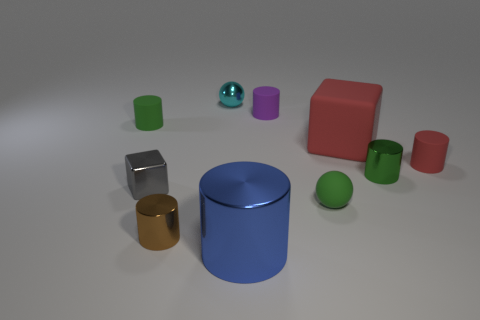There is a green rubber thing that is in front of the red rubber thing in front of the red cube; what shape is it?
Offer a very short reply. Sphere. Is there a blue ball made of the same material as the tiny brown cylinder?
Keep it short and to the point. No. There is a cylinder that is the same color as the large rubber object; what is its size?
Provide a short and direct response. Small. How many red objects are rubber cylinders or cubes?
Make the answer very short. 2. Are there any matte things of the same color as the big block?
Make the answer very short. Yes. What is the size of the blue cylinder that is made of the same material as the brown cylinder?
Offer a very short reply. Large. How many balls are small purple objects or large red things?
Provide a short and direct response. 0. Are there more tiny purple matte objects than things?
Keep it short and to the point. No. What number of blue things have the same size as the matte cube?
Your answer should be compact. 1. There is a rubber thing that is the same color as the big cube; what shape is it?
Give a very brief answer. Cylinder. 